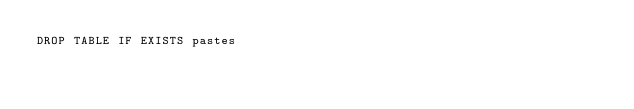Convert code to text. <code><loc_0><loc_0><loc_500><loc_500><_SQL_>DROP TABLE IF EXISTS pastes</code> 